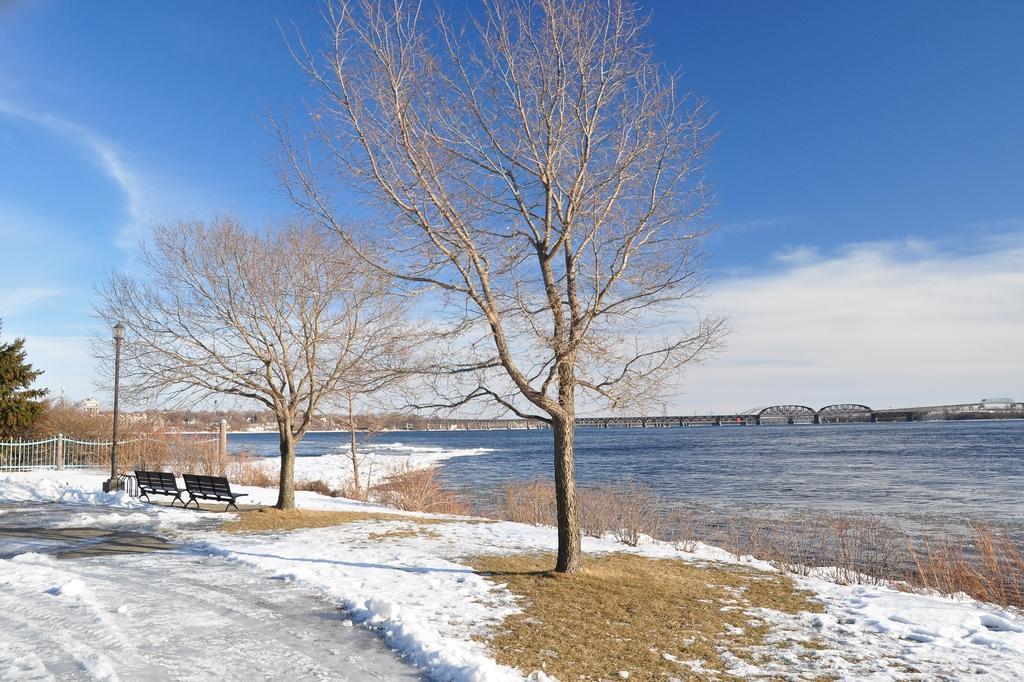In one or two sentences, can you explain what this image depicts? As we can see in the image there are trees, grass, benches, street lamp, fence and sky. In the background there is a bridge and there is water. 